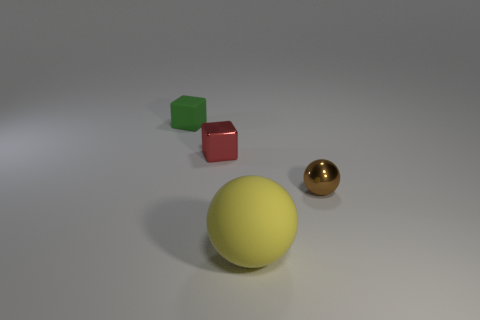Add 3 gray matte cubes. How many objects exist? 7 Subtract 1 cubes. How many cubes are left? 1 Subtract 0 yellow cubes. How many objects are left? 4 Subtract all green cubes. Subtract all blue cylinders. How many cubes are left? 1 Subtract all small shiny objects. Subtract all tiny brown metallic spheres. How many objects are left? 1 Add 2 green blocks. How many green blocks are left? 3 Add 1 tiny green objects. How many tiny green objects exist? 2 